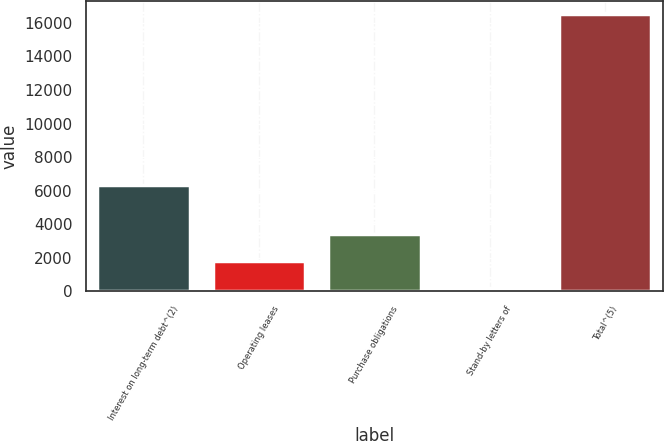<chart> <loc_0><loc_0><loc_500><loc_500><bar_chart><fcel>Interest on long-term debt^(2)<fcel>Operating leases<fcel>Purchase obligations<fcel>Stand-by letters of<fcel>Total^(5)<nl><fcel>6360<fcel>1801.3<fcel>3434.6<fcel>168<fcel>16501<nl></chart> 